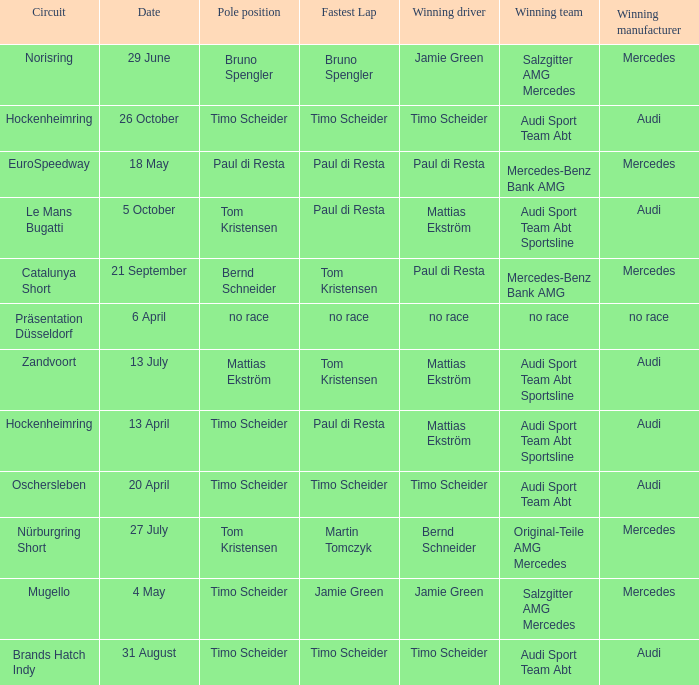Could you parse the entire table as a dict? {'header': ['Circuit', 'Date', 'Pole position', 'Fastest Lap', 'Winning driver', 'Winning team', 'Winning manufacturer'], 'rows': [['Norisring', '29 June', 'Bruno Spengler', 'Bruno Spengler', 'Jamie Green', 'Salzgitter AMG Mercedes', 'Mercedes'], ['Hockenheimring', '26 October', 'Timo Scheider', 'Timo Scheider', 'Timo Scheider', 'Audi Sport Team Abt', 'Audi'], ['EuroSpeedway', '18 May', 'Paul di Resta', 'Paul di Resta', 'Paul di Resta', 'Mercedes-Benz Bank AMG', 'Mercedes'], ['Le Mans Bugatti', '5 October', 'Tom Kristensen', 'Paul di Resta', 'Mattias Ekström', 'Audi Sport Team Abt Sportsline', 'Audi'], ['Catalunya Short', '21 September', 'Bernd Schneider', 'Tom Kristensen', 'Paul di Resta', 'Mercedes-Benz Bank AMG', 'Mercedes'], ['Präsentation Düsseldorf', '6 April', 'no race', 'no race', 'no race', 'no race', 'no race'], ['Zandvoort', '13 July', 'Mattias Ekström', 'Tom Kristensen', 'Mattias Ekström', 'Audi Sport Team Abt Sportsline', 'Audi'], ['Hockenheimring', '13 April', 'Timo Scheider', 'Paul di Resta', 'Mattias Ekström', 'Audi Sport Team Abt Sportsline', 'Audi'], ['Oschersleben', '20 April', 'Timo Scheider', 'Timo Scheider', 'Timo Scheider', 'Audi Sport Team Abt', 'Audi'], ['Nürburgring Short', '27 July', 'Tom Kristensen', 'Martin Tomczyk', 'Bernd Schneider', 'Original-Teile AMG Mercedes', 'Mercedes'], ['Mugello', '4 May', 'Timo Scheider', 'Jamie Green', 'Jamie Green', 'Salzgitter AMG Mercedes', 'Mercedes'], ['Brands Hatch Indy', '31 August', 'Timo Scheider', 'Timo Scheider', 'Timo Scheider', 'Audi Sport Team Abt', 'Audi']]} What is the winning team of the race on 31 August with Audi as the winning manufacturer and Timo Scheider as the winning driver? Audi Sport Team Abt. 